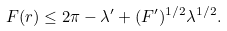Convert formula to latex. <formula><loc_0><loc_0><loc_500><loc_500>F ( r ) \leq 2 \pi - \lambda ^ { \prime } + ( F ^ { \prime } ) ^ { 1 / 2 } \lambda ^ { 1 / 2 } .</formula> 